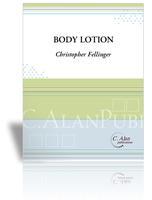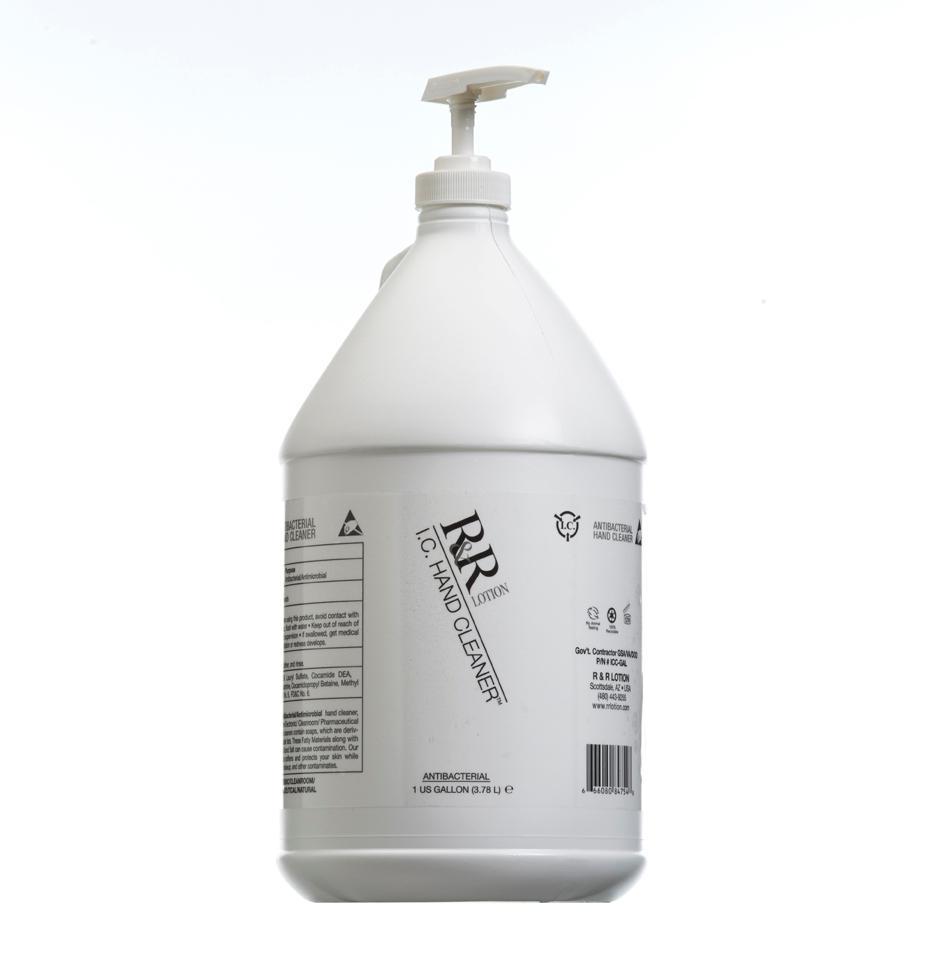The first image is the image on the left, the second image is the image on the right. Evaluate the accuracy of this statement regarding the images: "At least one image only has one bottle.". Is it true? Answer yes or no. Yes. 